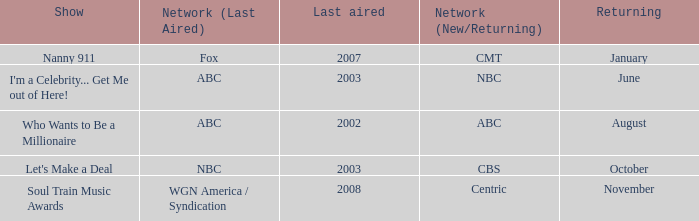Help me parse the entirety of this table. {'header': ['Show', 'Network (Last Aired)', 'Last aired', 'Network (New/Returning)', 'Returning'], 'rows': [['Nanny 911', 'Fox', '2007', 'CMT', 'January'], ["I'm a Celebrity... Get Me out of Here!", 'ABC', '2003', 'NBC', 'June'], ['Who Wants to Be a Millionaire', 'ABC', '2002', 'ABC', 'August'], ["Let's Make a Deal", 'NBC', '2003', 'CBS', 'October'], ['Soul Train Music Awards', 'WGN America / Syndication', '2008', 'Centric', 'November']]} When was the return of a show that last appeared on air in 2002? August. 